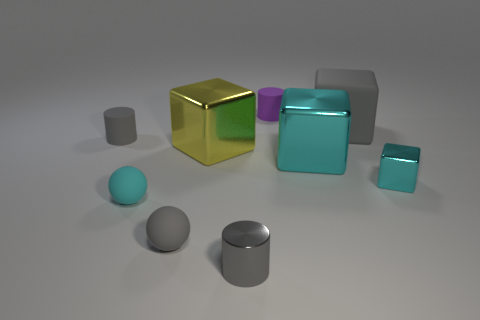Imagine this is a scene from a story. What narrative could these objects be a part of? Envisioning this as a narrative scene, these objects could represent a deserted playground of a futuristic society, where the metallic and rubbery textures hint at advanced materials science. The arrangement could symbolize a silent assembly of characters, with the gold cube as the leader surrounded by its colorful subjects. Each shape might represent a different entity or role within this society, with the positioning suggesting a recent gathering interrupted by an unseen event, leaving the objects frozen in time and space. 